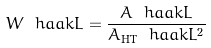Convert formula to latex. <formula><loc_0><loc_0><loc_500><loc_500>W \ h a a k { L } = \frac { A \ h a a k { L } } { A _ { \text {HT} } \ h a a k { L } ^ { 2 } }</formula> 